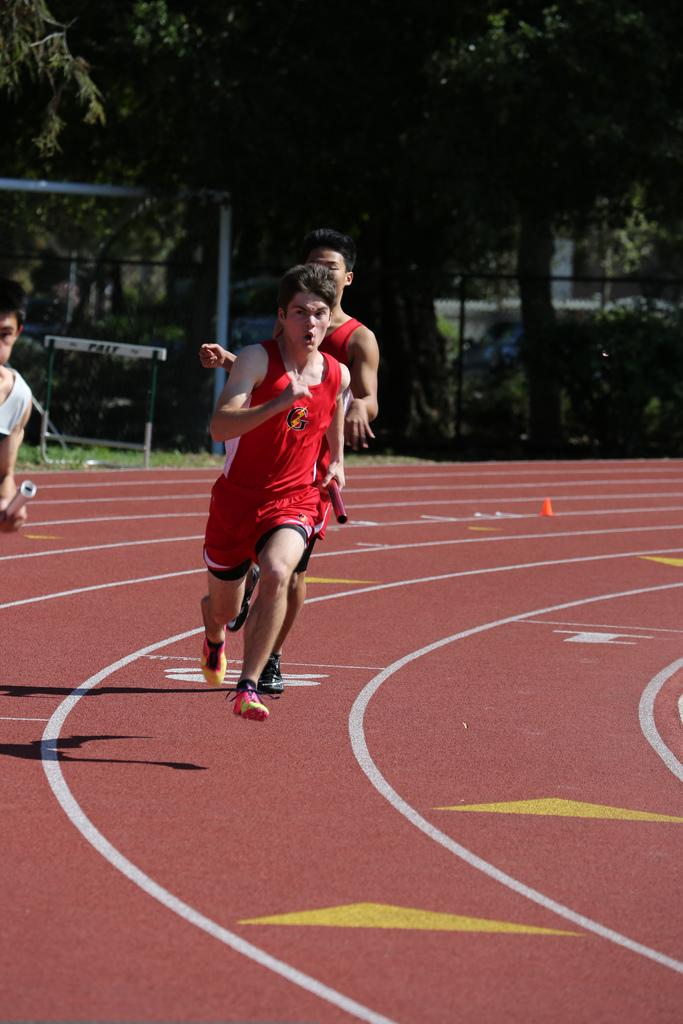What is the main feature of the image? There is a running track in the image. What are the people in the image doing? People are running on the track. What can be seen in the background of the image? There are trees, plants, grass, fencing, a pole, hurdles, and other objects present in the background. What type of sugar can be seen on the edge of the books in the image? There are no books or sugar present in the image; it features a running track with people running on it and various objects in the background. 